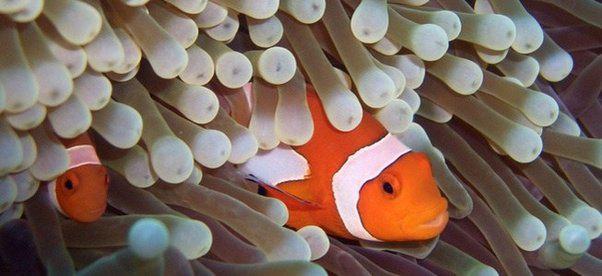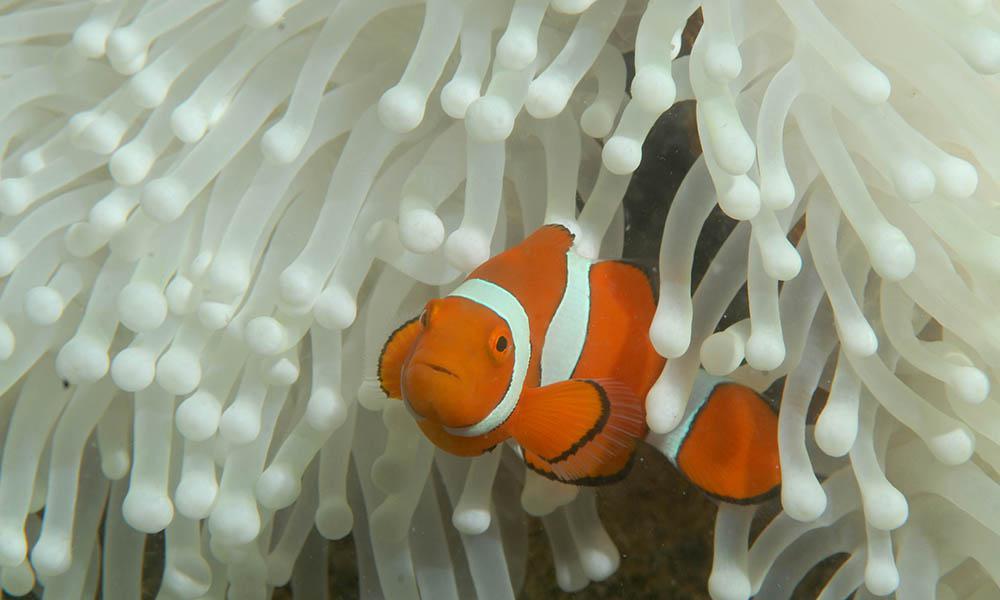The first image is the image on the left, the second image is the image on the right. Assess this claim about the two images: "One image shows a clown fish facing fully forward and surrounded by nipple-like structures.". Correct or not? Answer yes or no. No. 